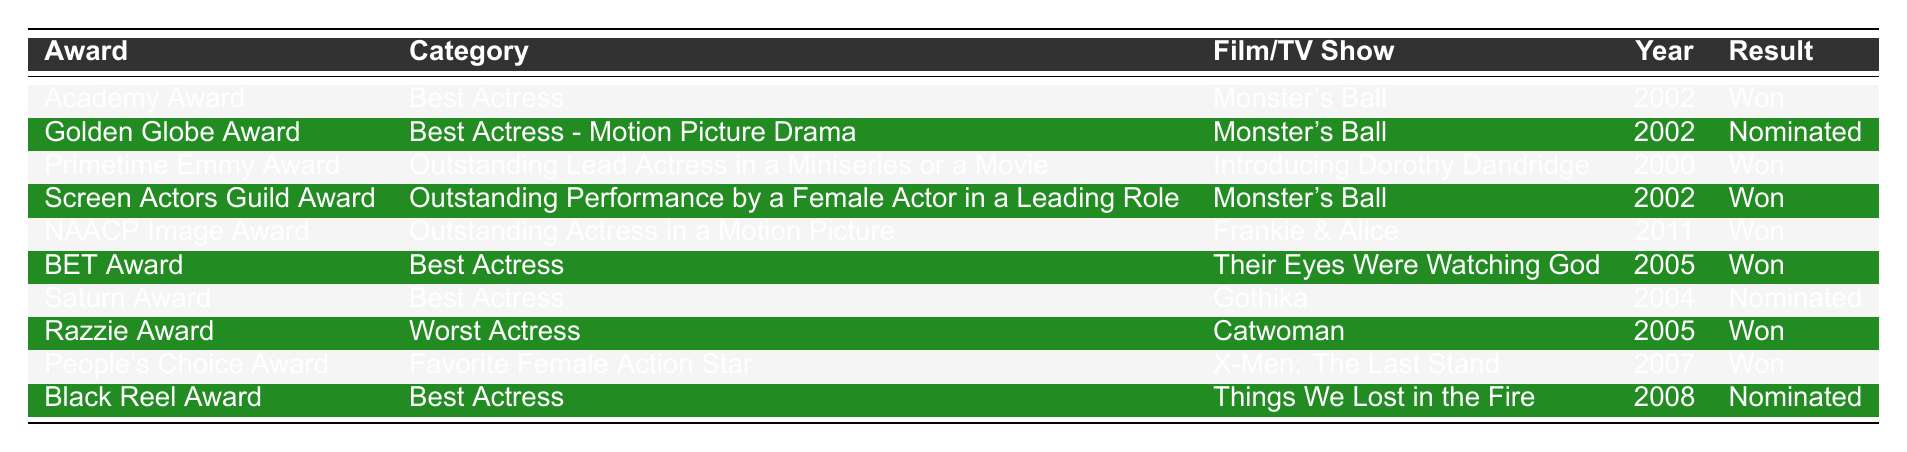What award did Halle Berry win for her performance in "Monster's Ball"? According to the table, Halle Berry won the Academy Award for Best Actress for her performance in "Monster's Ball" in 2002.
Answer: Academy Award How many awards has Halle Berry won according to this table? By counting the rows in the table, Halle Berry has won a total of 6 awards (Academy Award, Primetime Emmy Award, Screen Actors Guild Award, NAACP Image Award, BET Award, and Razzie Award).
Answer: 6 Which film earned Halle Berry an Emmy Award? The table shows that Halle Berry won the Primetime Emmy Award for Outstanding Lead Actress in a Miniseries or a Movie for "Introducing Dorothy Dandridge."
Answer: Introducing Dorothy Dandridge In what year did Halle Berry receive a nomination for a Saturn Award? The table lists that Halle Berry was nominated for the Saturn Award for Best Actress for the film "Gothika" in the year 2004.
Answer: 2004 Did Halle Berry receive any nominations for "Monster's Ball"? Yes, the table indicates that she was nominated for the Golden Globe Award for Best Actress - Motion Picture Drama for "Monster's Ball" in 2002.
Answer: Yes What is the total number of wins versus nominations for Halle Berry? Halle Berry won 6 awards and received 4 nominations (Golden Globe, Saturn, Black Reel). Thus, the total number of wins (6) is greater than the total number of nominations (4).
Answer: 6 wins, 4 nominations Which film won Halle Berry a Razzie Award, and what was the category? The table states that Halle Berry won the Razzie Award for Worst Actress for her performance in "Catwoman" in 2005.
Answer: Catwoman, Worst Actress Was Halle Berry nominated for an award for her role in "Things We Lost in the Fire"? The table indicates that she received a nomination for the Black Reel Award for Best Actress for "Things We Lost in the Fire" in 2008.
Answer: Yes Which award did Halle Berry win for her role in "Frankie & Alice"? Halle Berry won the NAACP Image Award for Outstanding Actress in a Motion Picture for her role in "Frankie & Alice" in 2011.
Answer: NAACP Image Award How many of Halle Berry's awards come from her roles in films released after 2000? The table shows that Halle Berry won 5 awards for films released after 2000 ("Monster's Ball," "Frankie & Alice," "Their Eyes Were Watching God," and "X-Men: The Last Stand"), and won one for "Catwoman" in 2005.
Answer: 5 